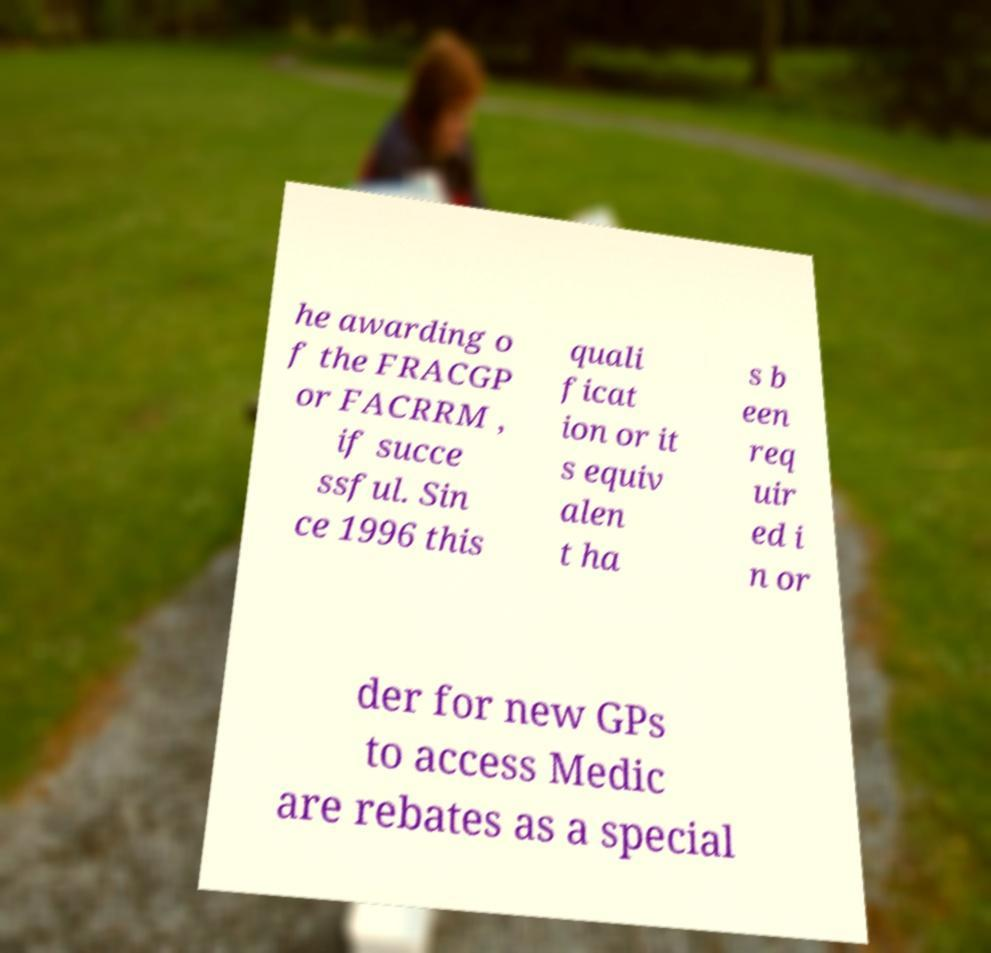Can you accurately transcribe the text from the provided image for me? he awarding o f the FRACGP or FACRRM , if succe ssful. Sin ce 1996 this quali ficat ion or it s equiv alen t ha s b een req uir ed i n or der for new GPs to access Medic are rebates as a special 